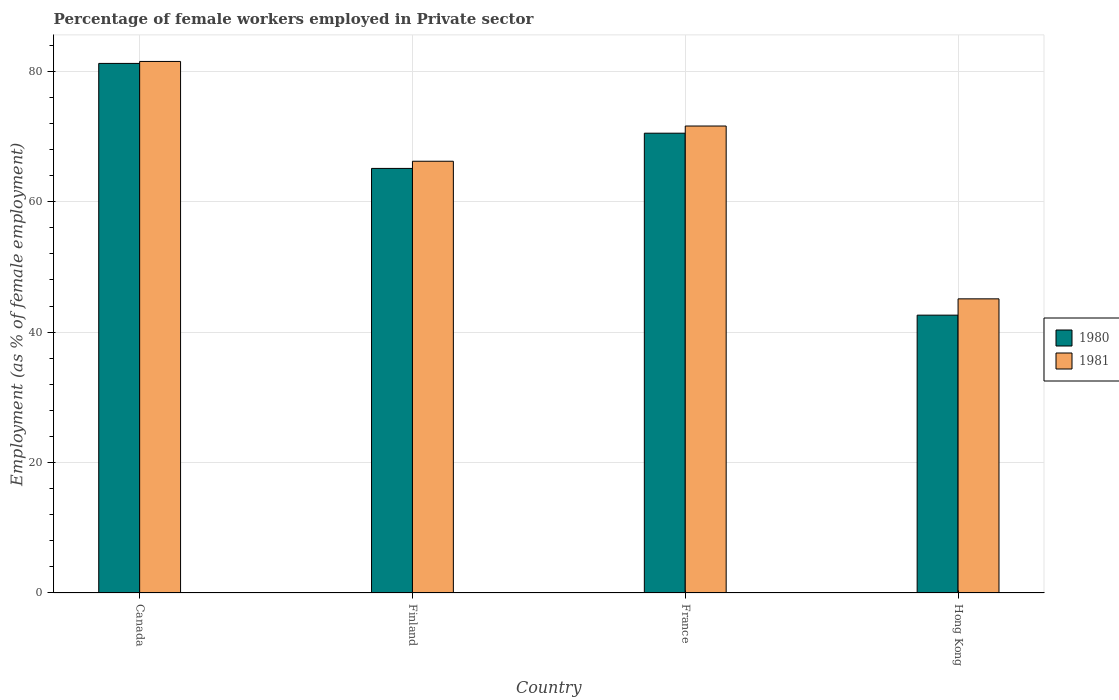How many different coloured bars are there?
Offer a very short reply. 2. Are the number of bars per tick equal to the number of legend labels?
Ensure brevity in your answer.  Yes. How many bars are there on the 4th tick from the left?
Your answer should be very brief. 2. What is the percentage of females employed in Private sector in 1980 in Finland?
Provide a succinct answer. 65.1. Across all countries, what is the maximum percentage of females employed in Private sector in 1980?
Provide a short and direct response. 81.2. Across all countries, what is the minimum percentage of females employed in Private sector in 1980?
Make the answer very short. 42.6. In which country was the percentage of females employed in Private sector in 1981 minimum?
Your answer should be very brief. Hong Kong. What is the total percentage of females employed in Private sector in 1980 in the graph?
Offer a very short reply. 259.4. What is the difference between the percentage of females employed in Private sector in 1981 in Finland and that in France?
Provide a succinct answer. -5.4. What is the average percentage of females employed in Private sector in 1980 per country?
Ensure brevity in your answer.  64.85. What is the difference between the percentage of females employed in Private sector of/in 1981 and percentage of females employed in Private sector of/in 1980 in Canada?
Your answer should be compact. 0.3. What is the ratio of the percentage of females employed in Private sector in 1980 in Canada to that in Finland?
Offer a terse response. 1.25. Is the percentage of females employed in Private sector in 1981 in Finland less than that in Hong Kong?
Your answer should be very brief. No. Is the difference between the percentage of females employed in Private sector in 1981 in Finland and France greater than the difference between the percentage of females employed in Private sector in 1980 in Finland and France?
Give a very brief answer. Yes. What is the difference between the highest and the second highest percentage of females employed in Private sector in 1981?
Your answer should be very brief. 15.3. What is the difference between the highest and the lowest percentage of females employed in Private sector in 1981?
Provide a succinct answer. 36.4. In how many countries, is the percentage of females employed in Private sector in 1981 greater than the average percentage of females employed in Private sector in 1981 taken over all countries?
Provide a short and direct response. 3. Is the sum of the percentage of females employed in Private sector in 1980 in Canada and Finland greater than the maximum percentage of females employed in Private sector in 1981 across all countries?
Offer a terse response. Yes. What does the 2nd bar from the left in Finland represents?
Your answer should be very brief. 1981. What does the 2nd bar from the right in France represents?
Provide a short and direct response. 1980. Are all the bars in the graph horizontal?
Your answer should be very brief. No. Are the values on the major ticks of Y-axis written in scientific E-notation?
Make the answer very short. No. How many legend labels are there?
Give a very brief answer. 2. What is the title of the graph?
Provide a succinct answer. Percentage of female workers employed in Private sector. What is the label or title of the X-axis?
Make the answer very short. Country. What is the label or title of the Y-axis?
Offer a terse response. Employment (as % of female employment). What is the Employment (as % of female employment) in 1980 in Canada?
Provide a succinct answer. 81.2. What is the Employment (as % of female employment) in 1981 in Canada?
Give a very brief answer. 81.5. What is the Employment (as % of female employment) of 1980 in Finland?
Your answer should be compact. 65.1. What is the Employment (as % of female employment) of 1981 in Finland?
Ensure brevity in your answer.  66.2. What is the Employment (as % of female employment) in 1980 in France?
Make the answer very short. 70.5. What is the Employment (as % of female employment) of 1981 in France?
Ensure brevity in your answer.  71.6. What is the Employment (as % of female employment) of 1980 in Hong Kong?
Offer a terse response. 42.6. What is the Employment (as % of female employment) in 1981 in Hong Kong?
Provide a succinct answer. 45.1. Across all countries, what is the maximum Employment (as % of female employment) in 1980?
Keep it short and to the point. 81.2. Across all countries, what is the maximum Employment (as % of female employment) in 1981?
Your response must be concise. 81.5. Across all countries, what is the minimum Employment (as % of female employment) of 1980?
Give a very brief answer. 42.6. Across all countries, what is the minimum Employment (as % of female employment) of 1981?
Your answer should be compact. 45.1. What is the total Employment (as % of female employment) of 1980 in the graph?
Ensure brevity in your answer.  259.4. What is the total Employment (as % of female employment) of 1981 in the graph?
Provide a short and direct response. 264.4. What is the difference between the Employment (as % of female employment) in 1980 in Canada and that in Finland?
Your response must be concise. 16.1. What is the difference between the Employment (as % of female employment) of 1981 in Canada and that in Finland?
Your answer should be compact. 15.3. What is the difference between the Employment (as % of female employment) of 1980 in Canada and that in France?
Give a very brief answer. 10.7. What is the difference between the Employment (as % of female employment) in 1981 in Canada and that in France?
Provide a succinct answer. 9.9. What is the difference between the Employment (as % of female employment) of 1980 in Canada and that in Hong Kong?
Your answer should be compact. 38.6. What is the difference between the Employment (as % of female employment) of 1981 in Canada and that in Hong Kong?
Offer a very short reply. 36.4. What is the difference between the Employment (as % of female employment) of 1980 in Finland and that in France?
Offer a terse response. -5.4. What is the difference between the Employment (as % of female employment) of 1981 in Finland and that in France?
Keep it short and to the point. -5.4. What is the difference between the Employment (as % of female employment) in 1980 in Finland and that in Hong Kong?
Provide a short and direct response. 22.5. What is the difference between the Employment (as % of female employment) of 1981 in Finland and that in Hong Kong?
Your answer should be very brief. 21.1. What is the difference between the Employment (as % of female employment) of 1980 in France and that in Hong Kong?
Offer a terse response. 27.9. What is the difference between the Employment (as % of female employment) in 1980 in Canada and the Employment (as % of female employment) in 1981 in France?
Make the answer very short. 9.6. What is the difference between the Employment (as % of female employment) in 1980 in Canada and the Employment (as % of female employment) in 1981 in Hong Kong?
Provide a succinct answer. 36.1. What is the difference between the Employment (as % of female employment) in 1980 in Finland and the Employment (as % of female employment) in 1981 in Hong Kong?
Provide a short and direct response. 20. What is the difference between the Employment (as % of female employment) of 1980 in France and the Employment (as % of female employment) of 1981 in Hong Kong?
Your answer should be very brief. 25.4. What is the average Employment (as % of female employment) of 1980 per country?
Provide a succinct answer. 64.85. What is the average Employment (as % of female employment) of 1981 per country?
Make the answer very short. 66.1. What is the ratio of the Employment (as % of female employment) of 1980 in Canada to that in Finland?
Give a very brief answer. 1.25. What is the ratio of the Employment (as % of female employment) of 1981 in Canada to that in Finland?
Keep it short and to the point. 1.23. What is the ratio of the Employment (as % of female employment) in 1980 in Canada to that in France?
Keep it short and to the point. 1.15. What is the ratio of the Employment (as % of female employment) of 1981 in Canada to that in France?
Provide a short and direct response. 1.14. What is the ratio of the Employment (as % of female employment) of 1980 in Canada to that in Hong Kong?
Offer a terse response. 1.91. What is the ratio of the Employment (as % of female employment) of 1981 in Canada to that in Hong Kong?
Offer a terse response. 1.81. What is the ratio of the Employment (as % of female employment) in 1980 in Finland to that in France?
Make the answer very short. 0.92. What is the ratio of the Employment (as % of female employment) of 1981 in Finland to that in France?
Offer a terse response. 0.92. What is the ratio of the Employment (as % of female employment) of 1980 in Finland to that in Hong Kong?
Offer a terse response. 1.53. What is the ratio of the Employment (as % of female employment) of 1981 in Finland to that in Hong Kong?
Offer a very short reply. 1.47. What is the ratio of the Employment (as % of female employment) of 1980 in France to that in Hong Kong?
Give a very brief answer. 1.65. What is the ratio of the Employment (as % of female employment) in 1981 in France to that in Hong Kong?
Your response must be concise. 1.59. What is the difference between the highest and the second highest Employment (as % of female employment) in 1981?
Your answer should be very brief. 9.9. What is the difference between the highest and the lowest Employment (as % of female employment) in 1980?
Make the answer very short. 38.6. What is the difference between the highest and the lowest Employment (as % of female employment) in 1981?
Your response must be concise. 36.4. 